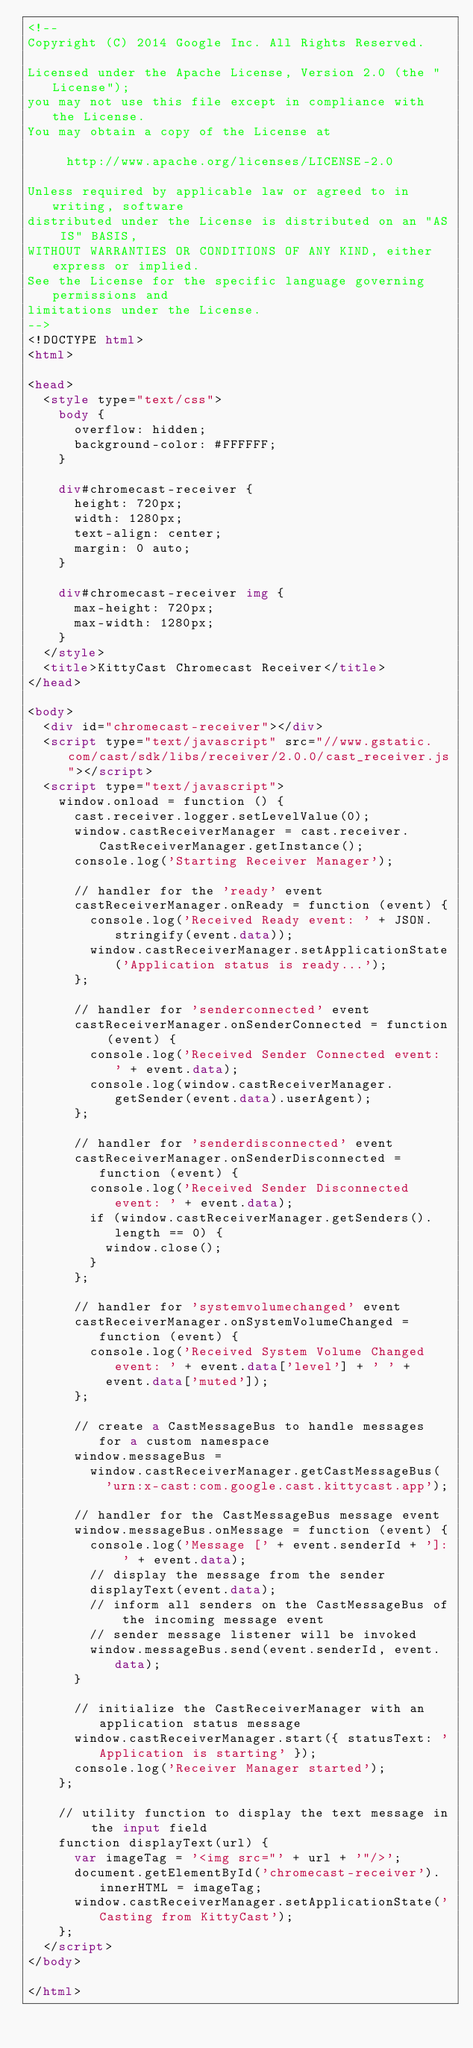<code> <loc_0><loc_0><loc_500><loc_500><_HTML_><!--
Copyright (C) 2014 Google Inc. All Rights Reserved.

Licensed under the Apache License, Version 2.0 (the "License");
you may not use this file except in compliance with the License.
You may obtain a copy of the License at

     http://www.apache.org/licenses/LICENSE-2.0

Unless required by applicable law or agreed to in writing, software
distributed under the License is distributed on an "AS IS" BASIS,
WITHOUT WARRANTIES OR CONDITIONS OF ANY KIND, either express or implied.
See the License for the specific language governing permissions and
limitations under the License.
-->
<!DOCTYPE html>
<html>

<head>
  <style type="text/css">
    body {
      overflow: hidden;
      background-color: #FFFFFF;
    }

    div#chromecast-receiver {
      height: 720px;
      width: 1280px;
      text-align: center;
      margin: 0 auto;
    }

    div#chromecast-receiver img {
      max-height: 720px;
      max-width: 1280px;
    }
  </style>
  <title>KittyCast Chromecast Receiver</title>
</head>

<body>
  <div id="chromecast-receiver"></div>
  <script type="text/javascript" src="//www.gstatic.com/cast/sdk/libs/receiver/2.0.0/cast_receiver.js"></script>
  <script type="text/javascript">
    window.onload = function () {
      cast.receiver.logger.setLevelValue(0);
      window.castReceiverManager = cast.receiver.CastReceiverManager.getInstance();
      console.log('Starting Receiver Manager');

      // handler for the 'ready' event
      castReceiverManager.onReady = function (event) {
        console.log('Received Ready event: ' + JSON.stringify(event.data));
        window.castReceiverManager.setApplicationState('Application status is ready...');
      };

      // handler for 'senderconnected' event
      castReceiverManager.onSenderConnected = function (event) {
        console.log('Received Sender Connected event: ' + event.data);
        console.log(window.castReceiverManager.getSender(event.data).userAgent);
      };

      // handler for 'senderdisconnected' event
      castReceiverManager.onSenderDisconnected = function (event) {
        console.log('Received Sender Disconnected event: ' + event.data);
        if (window.castReceiverManager.getSenders().length == 0) {
          window.close();
        }
      };

      // handler for 'systemvolumechanged' event
      castReceiverManager.onSystemVolumeChanged = function (event) {
        console.log('Received System Volume Changed event: ' + event.data['level'] + ' ' +
          event.data['muted']);
      };

      // create a CastMessageBus to handle messages for a custom namespace
      window.messageBus =
        window.castReceiverManager.getCastMessageBus(
          'urn:x-cast:com.google.cast.kittycast.app');

      // handler for the CastMessageBus message event
      window.messageBus.onMessage = function (event) {
        console.log('Message [' + event.senderId + ']: ' + event.data);
        // display the message from the sender
        displayText(event.data);
        // inform all senders on the CastMessageBus of the incoming message event
        // sender message listener will be invoked
        window.messageBus.send(event.senderId, event.data);
      }

      // initialize the CastReceiverManager with an application status message
      window.castReceiverManager.start({ statusText: 'Application is starting' });
      console.log('Receiver Manager started');
    };

    // utility function to display the text message in the input field
    function displayText(url) {
      var imageTag = '<img src="' + url + '"/>';
      document.getElementById('chromecast-receiver').innerHTML = imageTag;
      window.castReceiverManager.setApplicationState('Casting from KittyCast');
    };
  </script>
</body>

</html></code> 